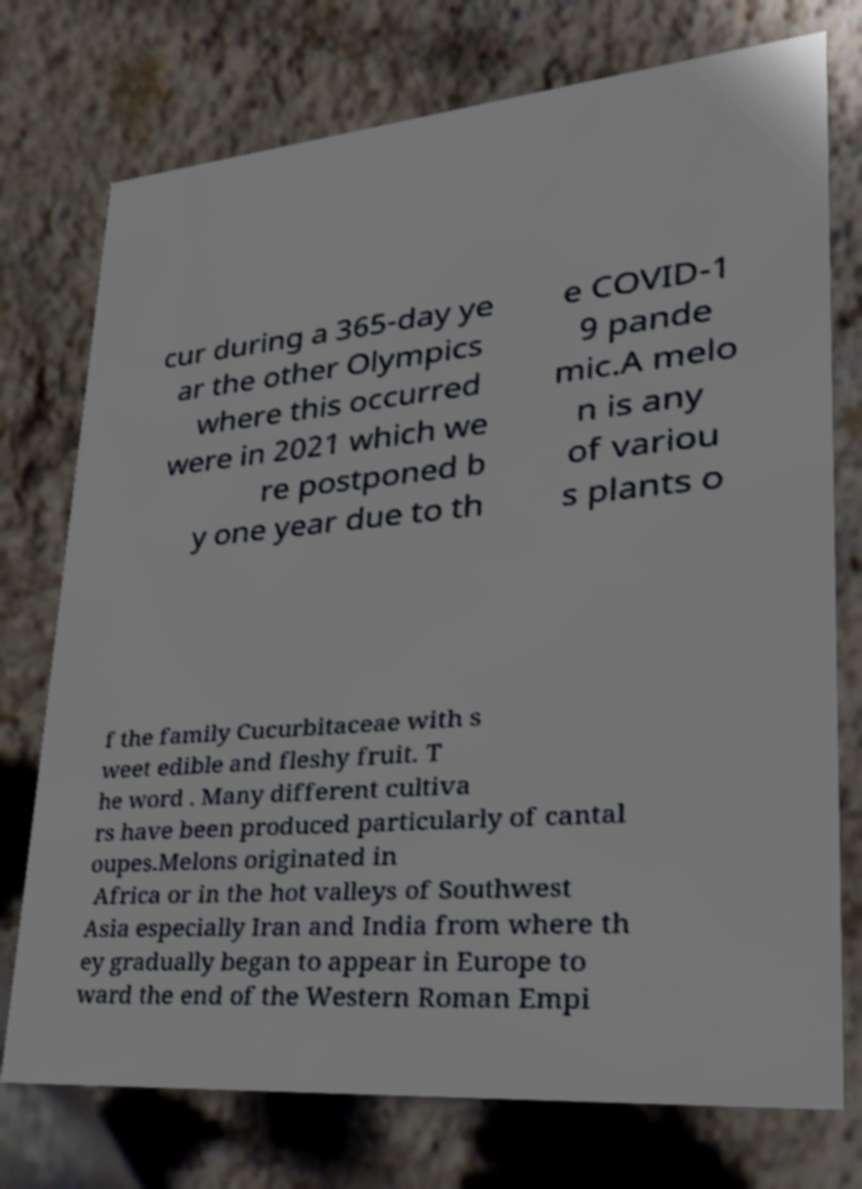Can you accurately transcribe the text from the provided image for me? cur during a 365-day ye ar the other Olympics where this occurred were in 2021 which we re postponed b y one year due to th e COVID-1 9 pande mic.A melo n is any of variou s plants o f the family Cucurbitaceae with s weet edible and fleshy fruit. T he word . Many different cultiva rs have been produced particularly of cantal oupes.Melons originated in Africa or in the hot valleys of Southwest Asia especially Iran and India from where th ey gradually began to appear in Europe to ward the end of the Western Roman Empi 